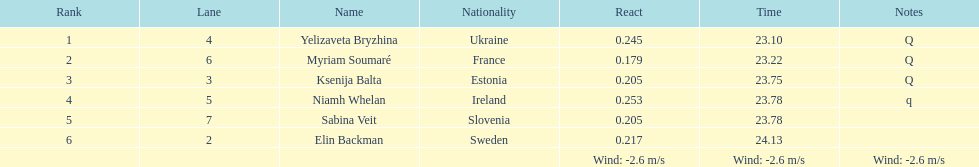How does the time of yelizaveta bryzhina compare to ksenija balta's time? 0.65. Would you be able to parse every entry in this table? {'header': ['Rank', 'Lane', 'Name', 'Nationality', 'React', 'Time', 'Notes'], 'rows': [['1', '4', 'Yelizaveta Bryzhina', 'Ukraine', '0.245', '23.10', 'Q'], ['2', '6', 'Myriam Soumaré', 'France', '0.179', '23.22', 'Q'], ['3', '3', 'Ksenija Balta', 'Estonia', '0.205', '23.75', 'Q'], ['4', '5', 'Niamh Whelan', 'Ireland', '0.253', '23.78', 'q'], ['5', '7', 'Sabina Veit', 'Slovenia', '0.205', '23.78', ''], ['6', '2', 'Elin Backman', 'Sweden', '0.217', '24.13', ''], ['', '', '', '', 'Wind: -2.6\xa0m/s', 'Wind: -2.6\xa0m/s', 'Wind: -2.6\xa0m/s']]} 